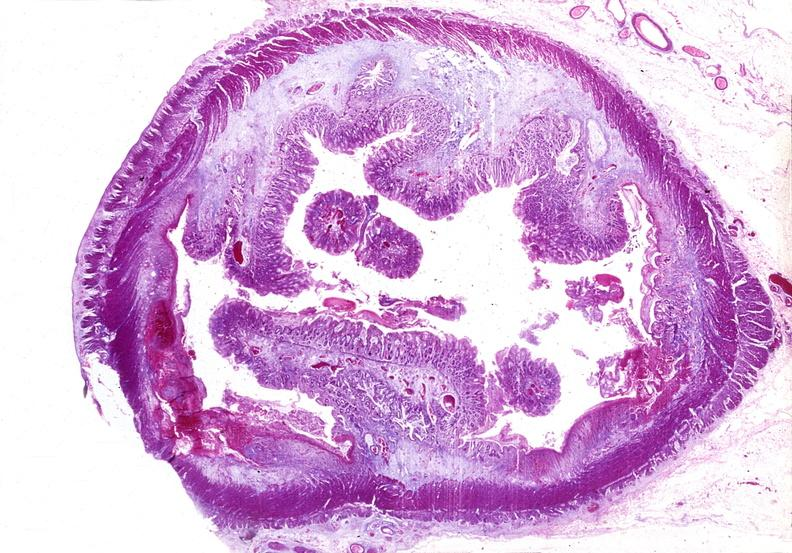does iron show colon, chronic ulcerative colitis, pseudopolyps?
Answer the question using a single word or phrase. No 